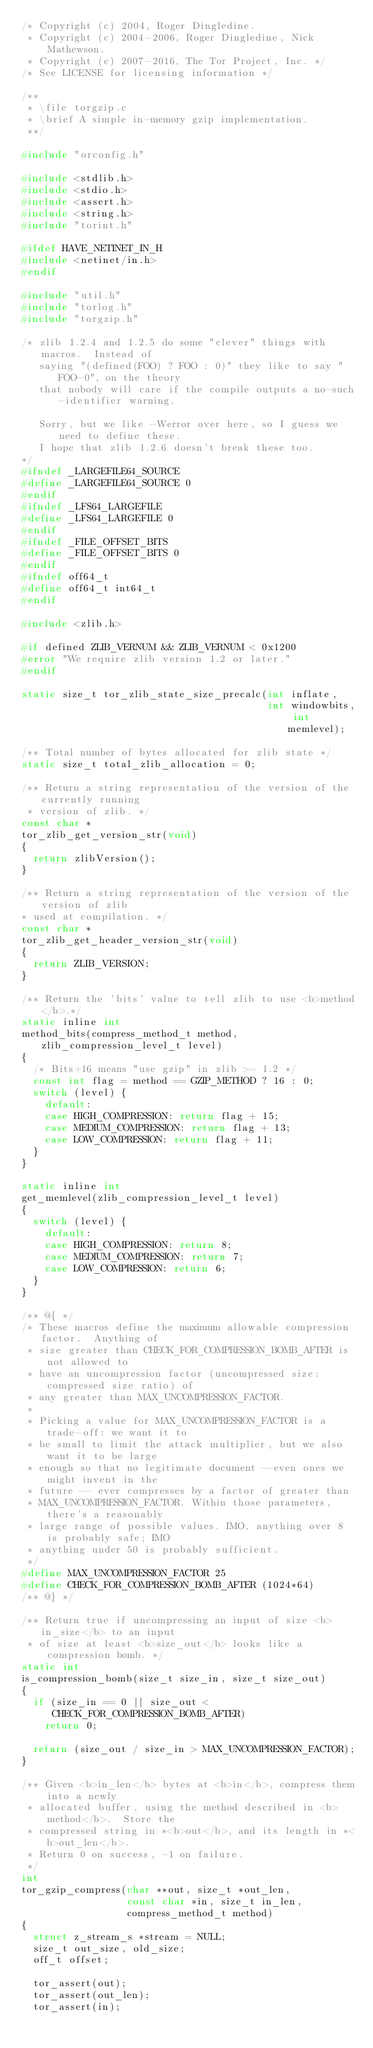<code> <loc_0><loc_0><loc_500><loc_500><_C_>/* Copyright (c) 2004, Roger Dingledine.
 * Copyright (c) 2004-2006, Roger Dingledine, Nick Mathewson.
 * Copyright (c) 2007-2016, The Tor Project, Inc. */
/* See LICENSE for licensing information */

/**
 * \file torgzip.c
 * \brief A simple in-memory gzip implementation.
 **/

#include "orconfig.h"

#include <stdlib.h>
#include <stdio.h>
#include <assert.h>
#include <string.h>
#include "torint.h"

#ifdef HAVE_NETINET_IN_H
#include <netinet/in.h>
#endif

#include "util.h"
#include "torlog.h"
#include "torgzip.h"

/* zlib 1.2.4 and 1.2.5 do some "clever" things with macros.  Instead of
   saying "(defined(FOO) ? FOO : 0)" they like to say "FOO-0", on the theory
   that nobody will care if the compile outputs a no-such-identifier warning.

   Sorry, but we like -Werror over here, so I guess we need to define these.
   I hope that zlib 1.2.6 doesn't break these too.
*/
#ifndef _LARGEFILE64_SOURCE
#define _LARGEFILE64_SOURCE 0
#endif
#ifndef _LFS64_LARGEFILE
#define _LFS64_LARGEFILE 0
#endif
#ifndef _FILE_OFFSET_BITS
#define _FILE_OFFSET_BITS 0
#endif
#ifndef off64_t
#define off64_t int64_t
#endif

#include <zlib.h>

#if defined ZLIB_VERNUM && ZLIB_VERNUM < 0x1200
#error "We require zlib version 1.2 or later."
#endif

static size_t tor_zlib_state_size_precalc(int inflate,
                                          int windowbits, int memlevel);

/** Total number of bytes allocated for zlib state */
static size_t total_zlib_allocation = 0;

/** Return a string representation of the version of the currently running
 * version of zlib. */
const char *
tor_zlib_get_version_str(void)
{
  return zlibVersion();
}

/** Return a string representation of the version of the version of zlib
* used at compilation. */
const char *
tor_zlib_get_header_version_str(void)
{
  return ZLIB_VERSION;
}

/** Return the 'bits' value to tell zlib to use <b>method</b>.*/
static inline int
method_bits(compress_method_t method, zlib_compression_level_t level)
{
  /* Bits+16 means "use gzip" in zlib >= 1.2 */
  const int flag = method == GZIP_METHOD ? 16 : 0;
  switch (level) {
    default:
    case HIGH_COMPRESSION: return flag + 15;
    case MEDIUM_COMPRESSION: return flag + 13;
    case LOW_COMPRESSION: return flag + 11;
  }
}

static inline int
get_memlevel(zlib_compression_level_t level)
{
  switch (level) {
    default:
    case HIGH_COMPRESSION: return 8;
    case MEDIUM_COMPRESSION: return 7;
    case LOW_COMPRESSION: return 6;
  }
}

/** @{ */
/* These macros define the maximum allowable compression factor.  Anything of
 * size greater than CHECK_FOR_COMPRESSION_BOMB_AFTER is not allowed to
 * have an uncompression factor (uncompressed size:compressed size ratio) of
 * any greater than MAX_UNCOMPRESSION_FACTOR.
 *
 * Picking a value for MAX_UNCOMPRESSION_FACTOR is a trade-off: we want it to
 * be small to limit the attack multiplier, but we also want it to be large
 * enough so that no legitimate document --even ones we might invent in the
 * future -- ever compresses by a factor of greater than
 * MAX_UNCOMPRESSION_FACTOR. Within those parameters, there's a reasonably
 * large range of possible values. IMO, anything over 8 is probably safe; IMO
 * anything under 50 is probably sufficient.
 */
#define MAX_UNCOMPRESSION_FACTOR 25
#define CHECK_FOR_COMPRESSION_BOMB_AFTER (1024*64)
/** @} */

/** Return true if uncompressing an input of size <b>in_size</b> to an input
 * of size at least <b>size_out</b> looks like a compression bomb. */
static int
is_compression_bomb(size_t size_in, size_t size_out)
{
  if (size_in == 0 || size_out < CHECK_FOR_COMPRESSION_BOMB_AFTER)
    return 0;

  return (size_out / size_in > MAX_UNCOMPRESSION_FACTOR);
}

/** Given <b>in_len</b> bytes at <b>in</b>, compress them into a newly
 * allocated buffer, using the method described in <b>method</b>.  Store the
 * compressed string in *<b>out</b>, and its length in *<b>out_len</b>.
 * Return 0 on success, -1 on failure.
 */
int
tor_gzip_compress(char **out, size_t *out_len,
                  const char *in, size_t in_len,
                  compress_method_t method)
{
  struct z_stream_s *stream = NULL;
  size_t out_size, old_size;
  off_t offset;

  tor_assert(out);
  tor_assert(out_len);
  tor_assert(in);</code> 